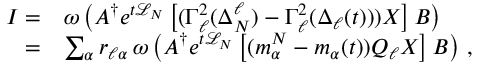Convert formula to latex. <formula><loc_0><loc_0><loc_500><loc_500>\begin{array} { r l } { I = } & { \omega \left ( A ^ { \dagger } e ^ { t \mathcal { L } _ { N } } \left [ ( \Gamma _ { \ell } ^ { 2 } ( \Delta _ { N } ^ { \ell } ) - \Gamma _ { \ell } ^ { 2 } ( \Delta _ { \ell } ( t ) ) ) X \right ] B \right ) } \\ { = } & { \sum _ { \alpha } r _ { \ell \alpha } \, \omega \left ( A ^ { \dagger } e ^ { t \mathcal { L } _ { N } } \left [ ( m _ { \alpha } ^ { N } - m _ { \alpha } ( t ) ) Q _ { \ell } X \right ] B \right ) \, , } \end{array}</formula> 